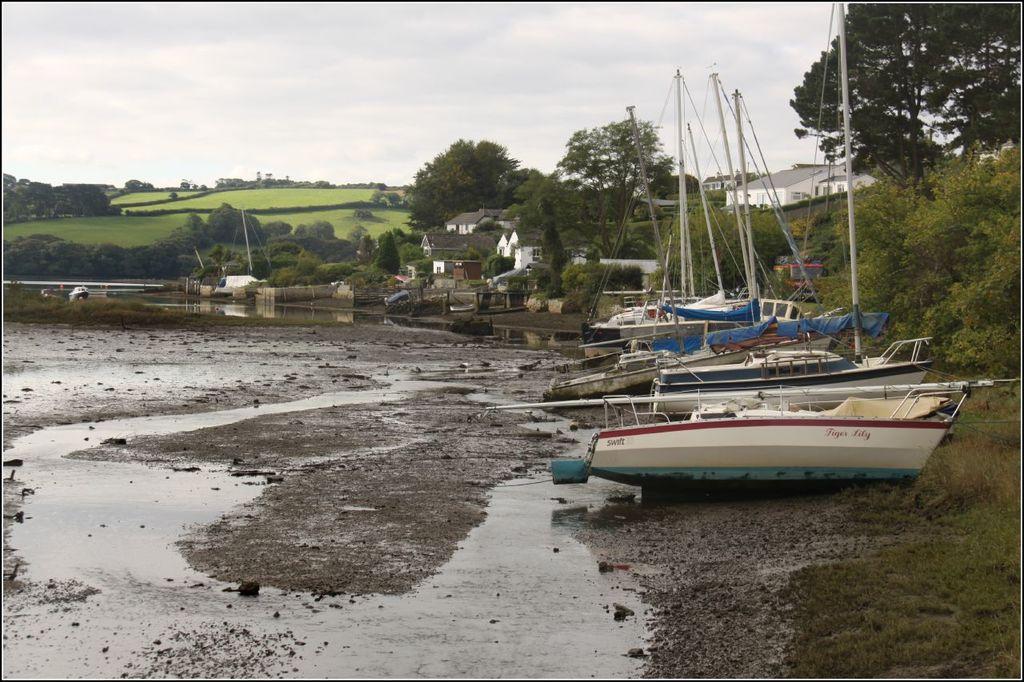How would you summarize this image in a sentence or two? In this image we can see the boats. And we can see the water. And we can see the trees, plants and grass. And we can see the buildings, clouds in the sky. 